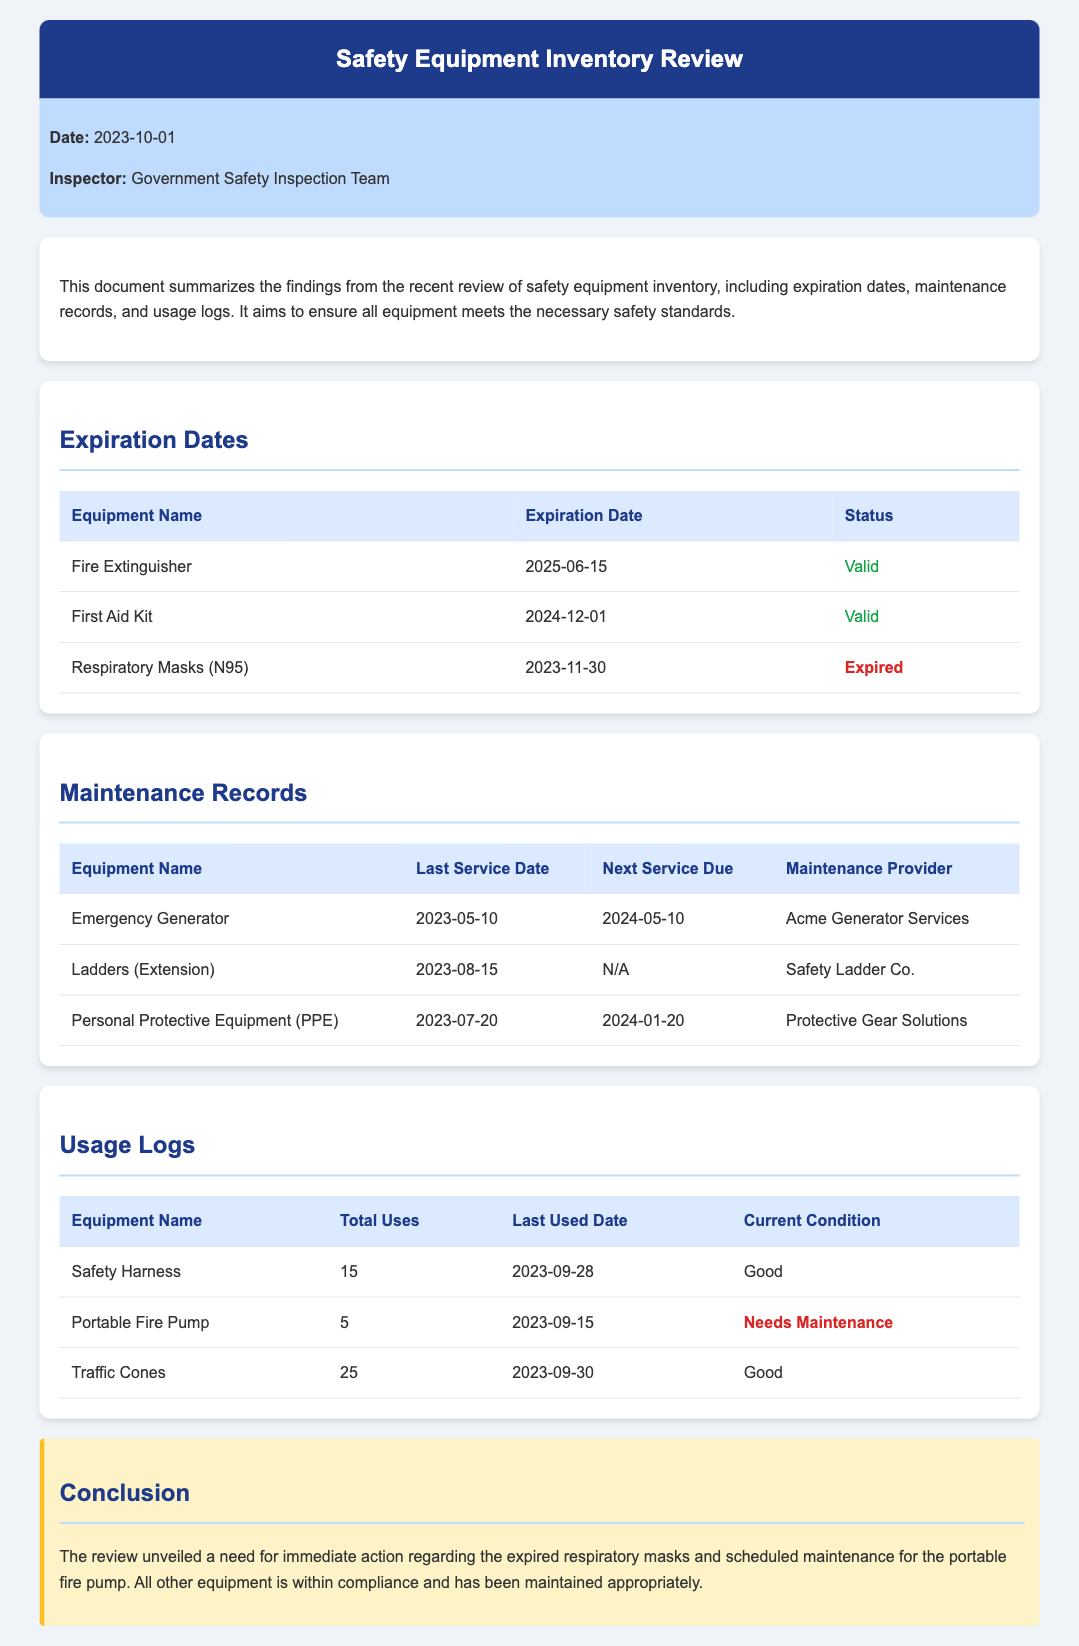What is the expiration date of the Fire Extinguisher? The expiration date of the Fire Extinguisher is mentioned in the Expiration Dates section of the document.
Answer: 2025-06-15 Which equipment has expired according to the review? The Expiration Dates section lists the equipment that has expired.
Answer: Respiratory Masks (N95) When was the last service performed on the Emergency Generator? The last service date for the Emergency Generator is found in the Maintenance Records section of the document.
Answer: 2023-05-10 What is the status of the Portable Fire Pump? The Usage Logs section indicates its current condition.
Answer: Needs Maintenance Who provided maintenance for the Personal Protective Equipment? The Maintenance Records section specifies the maintenance provider for the PPE.
Answer: Protective Gear Solutions How many times has the Safety Harness been used? The total uses of the Safety Harness are provided in the Usage Logs section of the document.
Answer: 15 What is the overall conclusion of the review? The conclusion summarizes the critical findings and actions needed regarding equipment compliance.
Answer: Immediate action regarding the expired respiratory masks and scheduled maintenance for the portable fire pump What is the total number of valid equipment listed? The Expiration Dates section contains equipment with valid statuses that can be counted.
Answer: 2 